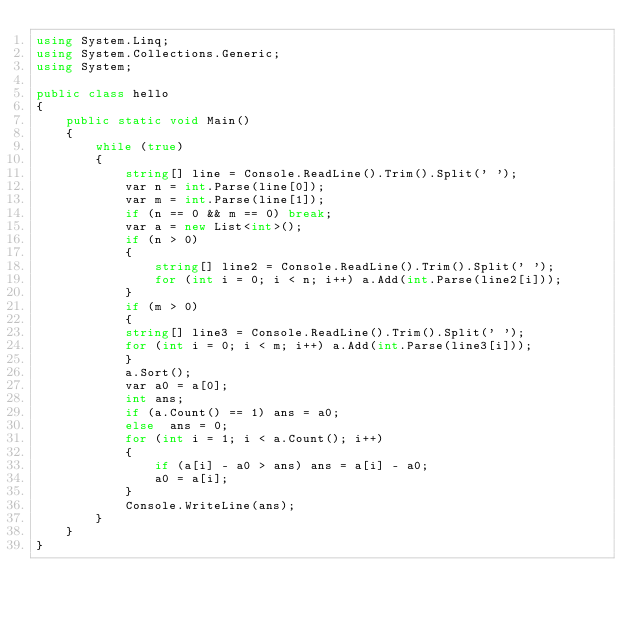Convert code to text. <code><loc_0><loc_0><loc_500><loc_500><_C#_>using System.Linq;
using System.Collections.Generic;
using System;

public class hello
{
    public static void Main()
    {
        while (true)
        {
            string[] line = Console.ReadLine().Trim().Split(' ');
            var n = int.Parse(line[0]);
            var m = int.Parse(line[1]);
            if (n == 0 && m == 0) break;
            var a = new List<int>();
            if (n > 0)
            {
                string[] line2 = Console.ReadLine().Trim().Split(' ');
                for (int i = 0; i < n; i++) a.Add(int.Parse(line2[i]));
            }
            if (m > 0)
            {
            string[] line3 = Console.ReadLine().Trim().Split(' ');
            for (int i = 0; i < m; i++) a.Add(int.Parse(line3[i]));
            }
            a.Sort();
            var a0 = a[0];
            int ans;
            if (a.Count() == 1) ans = a0;
            else  ans = 0;
            for (int i = 1; i < a.Count(); i++)
            {
                if (a[i] - a0 > ans) ans = a[i] - a0;
                a0 = a[i];
            }
            Console.WriteLine(ans);
        }
    }
}</code> 